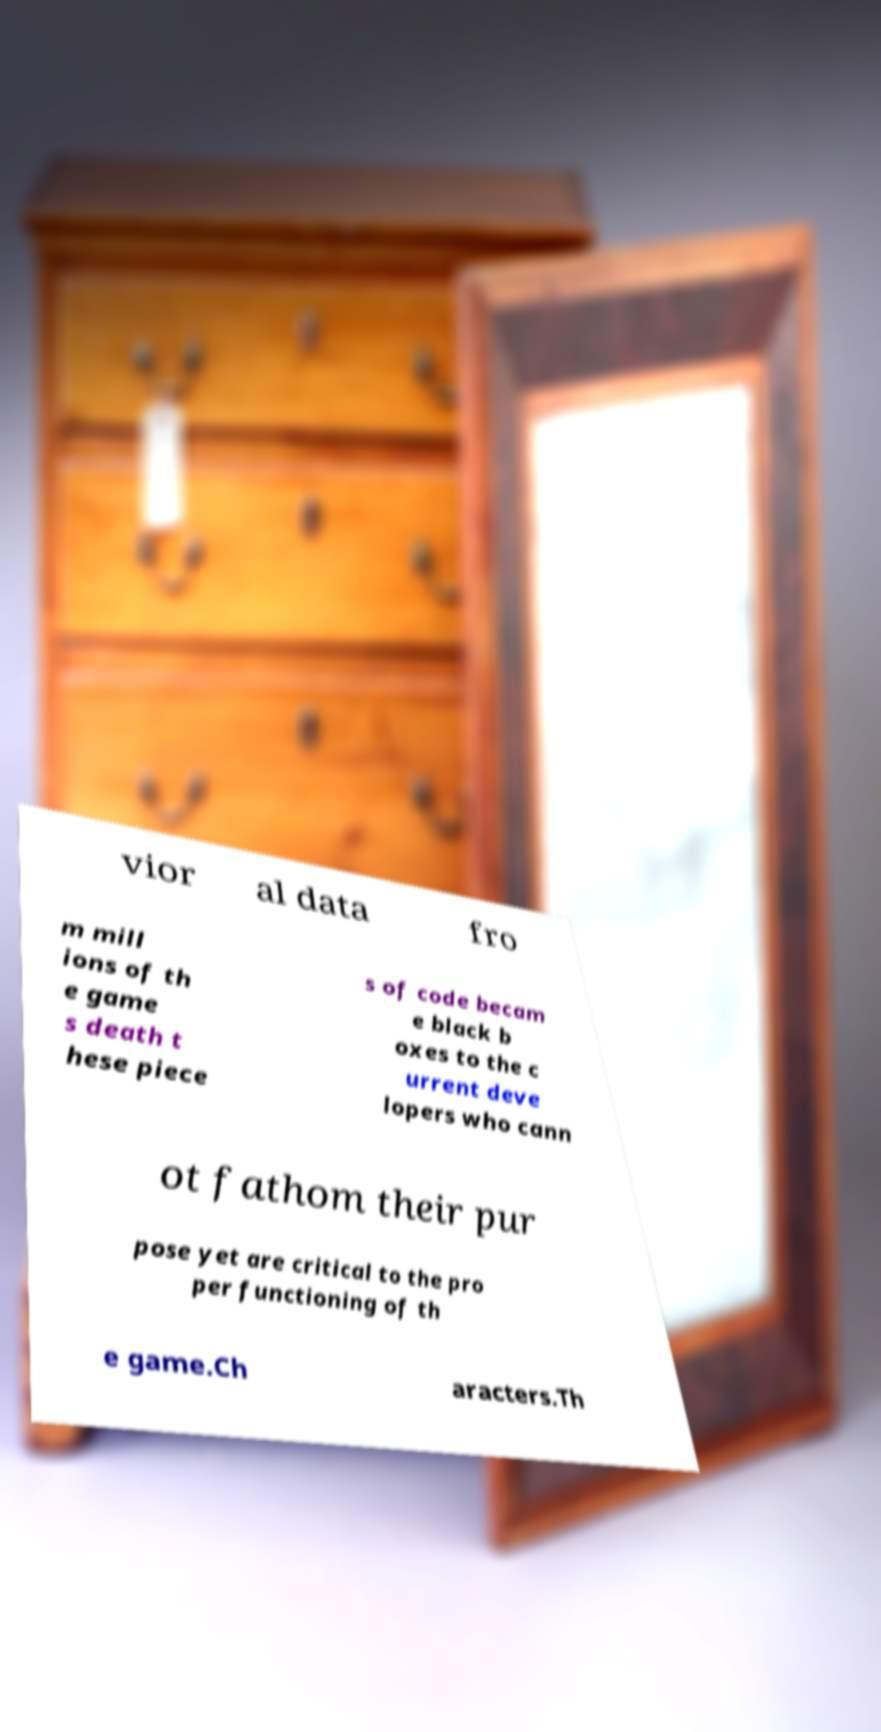Please read and relay the text visible in this image. What does it say? vior al data fro m mill ions of th e game s death t hese piece s of code becam e black b oxes to the c urrent deve lopers who cann ot fathom their pur pose yet are critical to the pro per functioning of th e game.Ch aracters.Th 